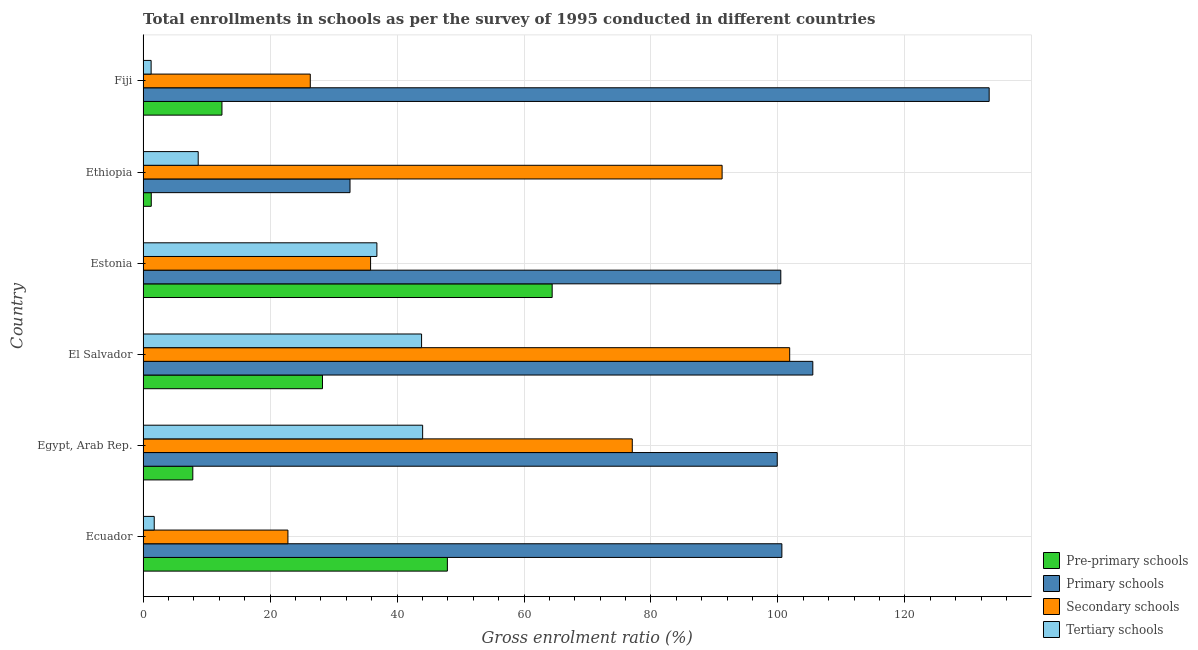How many different coloured bars are there?
Ensure brevity in your answer.  4. Are the number of bars per tick equal to the number of legend labels?
Give a very brief answer. Yes. Are the number of bars on each tick of the Y-axis equal?
Provide a succinct answer. Yes. How many bars are there on the 5th tick from the bottom?
Your answer should be compact. 4. What is the label of the 3rd group of bars from the top?
Your answer should be compact. Estonia. In how many cases, is the number of bars for a given country not equal to the number of legend labels?
Ensure brevity in your answer.  0. What is the gross enrolment ratio in tertiary schools in Egypt, Arab Rep.?
Offer a terse response. 44.04. Across all countries, what is the maximum gross enrolment ratio in tertiary schools?
Offer a terse response. 44.04. Across all countries, what is the minimum gross enrolment ratio in pre-primary schools?
Your answer should be very brief. 1.29. In which country was the gross enrolment ratio in pre-primary schools maximum?
Offer a very short reply. Estonia. In which country was the gross enrolment ratio in tertiary schools minimum?
Your answer should be compact. Fiji. What is the total gross enrolment ratio in primary schools in the graph?
Ensure brevity in your answer.  572.3. What is the difference between the gross enrolment ratio in tertiary schools in Estonia and that in Ethiopia?
Provide a short and direct response. 28.15. What is the difference between the gross enrolment ratio in secondary schools in Ecuador and the gross enrolment ratio in primary schools in El Salvador?
Keep it short and to the point. -82.67. What is the average gross enrolment ratio in tertiary schools per country?
Your response must be concise. 22.74. What is the difference between the gross enrolment ratio in secondary schools and gross enrolment ratio in pre-primary schools in Estonia?
Offer a very short reply. -28.6. What is the ratio of the gross enrolment ratio in primary schools in Egypt, Arab Rep. to that in Estonia?
Your response must be concise. 0.99. What is the difference between the highest and the second highest gross enrolment ratio in secondary schools?
Your response must be concise. 10.64. What is the difference between the highest and the lowest gross enrolment ratio in primary schools?
Offer a very short reply. 100.67. What does the 3rd bar from the top in Ecuador represents?
Offer a terse response. Primary schools. What does the 4th bar from the bottom in Estonia represents?
Give a very brief answer. Tertiary schools. How many bars are there?
Offer a very short reply. 24. How many countries are there in the graph?
Ensure brevity in your answer.  6. Are the values on the major ticks of X-axis written in scientific E-notation?
Your response must be concise. No. What is the title of the graph?
Provide a succinct answer. Total enrollments in schools as per the survey of 1995 conducted in different countries. What is the Gross enrolment ratio (%) in Pre-primary schools in Ecuador?
Provide a succinct answer. 47.93. What is the Gross enrolment ratio (%) of Primary schools in Ecuador?
Your answer should be compact. 100.62. What is the Gross enrolment ratio (%) of Secondary schools in Ecuador?
Make the answer very short. 22.81. What is the Gross enrolment ratio (%) in Tertiary schools in Ecuador?
Your answer should be very brief. 1.76. What is the Gross enrolment ratio (%) of Pre-primary schools in Egypt, Arab Rep.?
Your response must be concise. 7.84. What is the Gross enrolment ratio (%) of Primary schools in Egypt, Arab Rep.?
Your answer should be very brief. 99.88. What is the Gross enrolment ratio (%) in Secondary schools in Egypt, Arab Rep.?
Your answer should be compact. 77.05. What is the Gross enrolment ratio (%) in Tertiary schools in Egypt, Arab Rep.?
Provide a succinct answer. 44.04. What is the Gross enrolment ratio (%) in Pre-primary schools in El Salvador?
Offer a very short reply. 28.26. What is the Gross enrolment ratio (%) of Primary schools in El Salvador?
Provide a succinct answer. 105.49. What is the Gross enrolment ratio (%) in Secondary schools in El Salvador?
Provide a succinct answer. 101.85. What is the Gross enrolment ratio (%) of Tertiary schools in El Salvador?
Provide a succinct answer. 43.87. What is the Gross enrolment ratio (%) in Pre-primary schools in Estonia?
Provide a succinct answer. 64.44. What is the Gross enrolment ratio (%) in Primary schools in Estonia?
Your response must be concise. 100.45. What is the Gross enrolment ratio (%) of Secondary schools in Estonia?
Your answer should be compact. 35.84. What is the Gross enrolment ratio (%) of Tertiary schools in Estonia?
Provide a short and direct response. 36.83. What is the Gross enrolment ratio (%) of Pre-primary schools in Ethiopia?
Offer a very short reply. 1.29. What is the Gross enrolment ratio (%) of Primary schools in Ethiopia?
Make the answer very short. 32.6. What is the Gross enrolment ratio (%) in Secondary schools in Ethiopia?
Your answer should be compact. 91.2. What is the Gross enrolment ratio (%) of Tertiary schools in Ethiopia?
Your response must be concise. 8.68. What is the Gross enrolment ratio (%) of Pre-primary schools in Fiji?
Offer a terse response. 12.42. What is the Gross enrolment ratio (%) of Primary schools in Fiji?
Make the answer very short. 133.27. What is the Gross enrolment ratio (%) of Secondary schools in Fiji?
Your answer should be very brief. 26.34. What is the Gross enrolment ratio (%) in Tertiary schools in Fiji?
Provide a succinct answer. 1.27. Across all countries, what is the maximum Gross enrolment ratio (%) in Pre-primary schools?
Make the answer very short. 64.44. Across all countries, what is the maximum Gross enrolment ratio (%) of Primary schools?
Ensure brevity in your answer.  133.27. Across all countries, what is the maximum Gross enrolment ratio (%) in Secondary schools?
Keep it short and to the point. 101.85. Across all countries, what is the maximum Gross enrolment ratio (%) in Tertiary schools?
Provide a short and direct response. 44.04. Across all countries, what is the minimum Gross enrolment ratio (%) in Pre-primary schools?
Your answer should be compact. 1.29. Across all countries, what is the minimum Gross enrolment ratio (%) in Primary schools?
Ensure brevity in your answer.  32.6. Across all countries, what is the minimum Gross enrolment ratio (%) in Secondary schools?
Make the answer very short. 22.81. Across all countries, what is the minimum Gross enrolment ratio (%) in Tertiary schools?
Ensure brevity in your answer.  1.27. What is the total Gross enrolment ratio (%) of Pre-primary schools in the graph?
Offer a very short reply. 162.18. What is the total Gross enrolment ratio (%) in Primary schools in the graph?
Offer a very short reply. 572.3. What is the total Gross enrolment ratio (%) in Secondary schools in the graph?
Keep it short and to the point. 355.09. What is the total Gross enrolment ratio (%) of Tertiary schools in the graph?
Provide a succinct answer. 136.45. What is the difference between the Gross enrolment ratio (%) of Pre-primary schools in Ecuador and that in Egypt, Arab Rep.?
Ensure brevity in your answer.  40.09. What is the difference between the Gross enrolment ratio (%) of Primary schools in Ecuador and that in Egypt, Arab Rep.?
Your response must be concise. 0.73. What is the difference between the Gross enrolment ratio (%) of Secondary schools in Ecuador and that in Egypt, Arab Rep.?
Your answer should be compact. -54.24. What is the difference between the Gross enrolment ratio (%) in Tertiary schools in Ecuador and that in Egypt, Arab Rep.?
Your answer should be very brief. -42.28. What is the difference between the Gross enrolment ratio (%) of Pre-primary schools in Ecuador and that in El Salvador?
Offer a very short reply. 19.67. What is the difference between the Gross enrolment ratio (%) of Primary schools in Ecuador and that in El Salvador?
Ensure brevity in your answer.  -4.87. What is the difference between the Gross enrolment ratio (%) of Secondary schools in Ecuador and that in El Salvador?
Offer a very short reply. -79.03. What is the difference between the Gross enrolment ratio (%) of Tertiary schools in Ecuador and that in El Salvador?
Your response must be concise. -42.11. What is the difference between the Gross enrolment ratio (%) in Pre-primary schools in Ecuador and that in Estonia?
Give a very brief answer. -16.51. What is the difference between the Gross enrolment ratio (%) in Primary schools in Ecuador and that in Estonia?
Make the answer very short. 0.17. What is the difference between the Gross enrolment ratio (%) in Secondary schools in Ecuador and that in Estonia?
Give a very brief answer. -13.02. What is the difference between the Gross enrolment ratio (%) of Tertiary schools in Ecuador and that in Estonia?
Your response must be concise. -35.07. What is the difference between the Gross enrolment ratio (%) of Pre-primary schools in Ecuador and that in Ethiopia?
Offer a very short reply. 46.64. What is the difference between the Gross enrolment ratio (%) of Primary schools in Ecuador and that in Ethiopia?
Your answer should be compact. 68.02. What is the difference between the Gross enrolment ratio (%) in Secondary schools in Ecuador and that in Ethiopia?
Provide a succinct answer. -68.39. What is the difference between the Gross enrolment ratio (%) of Tertiary schools in Ecuador and that in Ethiopia?
Make the answer very short. -6.92. What is the difference between the Gross enrolment ratio (%) of Pre-primary schools in Ecuador and that in Fiji?
Your response must be concise. 35.51. What is the difference between the Gross enrolment ratio (%) of Primary schools in Ecuador and that in Fiji?
Offer a very short reply. -32.65. What is the difference between the Gross enrolment ratio (%) in Secondary schools in Ecuador and that in Fiji?
Your answer should be compact. -3.52. What is the difference between the Gross enrolment ratio (%) of Tertiary schools in Ecuador and that in Fiji?
Provide a succinct answer. 0.49. What is the difference between the Gross enrolment ratio (%) of Pre-primary schools in Egypt, Arab Rep. and that in El Salvador?
Your answer should be very brief. -20.42. What is the difference between the Gross enrolment ratio (%) in Primary schools in Egypt, Arab Rep. and that in El Salvador?
Make the answer very short. -5.6. What is the difference between the Gross enrolment ratio (%) of Secondary schools in Egypt, Arab Rep. and that in El Salvador?
Offer a very short reply. -24.79. What is the difference between the Gross enrolment ratio (%) of Tertiary schools in Egypt, Arab Rep. and that in El Salvador?
Your answer should be compact. 0.17. What is the difference between the Gross enrolment ratio (%) of Pre-primary schools in Egypt, Arab Rep. and that in Estonia?
Offer a terse response. -56.6. What is the difference between the Gross enrolment ratio (%) in Primary schools in Egypt, Arab Rep. and that in Estonia?
Your answer should be compact. -0.56. What is the difference between the Gross enrolment ratio (%) of Secondary schools in Egypt, Arab Rep. and that in Estonia?
Ensure brevity in your answer.  41.22. What is the difference between the Gross enrolment ratio (%) in Tertiary schools in Egypt, Arab Rep. and that in Estonia?
Keep it short and to the point. 7.21. What is the difference between the Gross enrolment ratio (%) of Pre-primary schools in Egypt, Arab Rep. and that in Ethiopia?
Ensure brevity in your answer.  6.55. What is the difference between the Gross enrolment ratio (%) of Primary schools in Egypt, Arab Rep. and that in Ethiopia?
Give a very brief answer. 67.29. What is the difference between the Gross enrolment ratio (%) in Secondary schools in Egypt, Arab Rep. and that in Ethiopia?
Provide a succinct answer. -14.15. What is the difference between the Gross enrolment ratio (%) of Tertiary schools in Egypt, Arab Rep. and that in Ethiopia?
Offer a very short reply. 35.35. What is the difference between the Gross enrolment ratio (%) in Pre-primary schools in Egypt, Arab Rep. and that in Fiji?
Provide a short and direct response. -4.59. What is the difference between the Gross enrolment ratio (%) in Primary schools in Egypt, Arab Rep. and that in Fiji?
Make the answer very short. -33.38. What is the difference between the Gross enrolment ratio (%) of Secondary schools in Egypt, Arab Rep. and that in Fiji?
Your answer should be very brief. 50.72. What is the difference between the Gross enrolment ratio (%) in Tertiary schools in Egypt, Arab Rep. and that in Fiji?
Your answer should be very brief. 42.77. What is the difference between the Gross enrolment ratio (%) in Pre-primary schools in El Salvador and that in Estonia?
Provide a short and direct response. -36.18. What is the difference between the Gross enrolment ratio (%) of Primary schools in El Salvador and that in Estonia?
Ensure brevity in your answer.  5.04. What is the difference between the Gross enrolment ratio (%) in Secondary schools in El Salvador and that in Estonia?
Offer a very short reply. 66.01. What is the difference between the Gross enrolment ratio (%) of Tertiary schools in El Salvador and that in Estonia?
Ensure brevity in your answer.  7.04. What is the difference between the Gross enrolment ratio (%) in Pre-primary schools in El Salvador and that in Ethiopia?
Make the answer very short. 26.97. What is the difference between the Gross enrolment ratio (%) of Primary schools in El Salvador and that in Ethiopia?
Your answer should be very brief. 72.89. What is the difference between the Gross enrolment ratio (%) in Secondary schools in El Salvador and that in Ethiopia?
Make the answer very short. 10.64. What is the difference between the Gross enrolment ratio (%) in Tertiary schools in El Salvador and that in Ethiopia?
Make the answer very short. 35.18. What is the difference between the Gross enrolment ratio (%) of Pre-primary schools in El Salvador and that in Fiji?
Provide a succinct answer. 15.83. What is the difference between the Gross enrolment ratio (%) of Primary schools in El Salvador and that in Fiji?
Your answer should be very brief. -27.78. What is the difference between the Gross enrolment ratio (%) in Secondary schools in El Salvador and that in Fiji?
Your response must be concise. 75.51. What is the difference between the Gross enrolment ratio (%) in Tertiary schools in El Salvador and that in Fiji?
Ensure brevity in your answer.  42.6. What is the difference between the Gross enrolment ratio (%) in Pre-primary schools in Estonia and that in Ethiopia?
Your answer should be very brief. 63.15. What is the difference between the Gross enrolment ratio (%) of Primary schools in Estonia and that in Ethiopia?
Your answer should be compact. 67.85. What is the difference between the Gross enrolment ratio (%) in Secondary schools in Estonia and that in Ethiopia?
Provide a succinct answer. -55.37. What is the difference between the Gross enrolment ratio (%) of Tertiary schools in Estonia and that in Ethiopia?
Offer a very short reply. 28.15. What is the difference between the Gross enrolment ratio (%) in Pre-primary schools in Estonia and that in Fiji?
Make the answer very short. 52.01. What is the difference between the Gross enrolment ratio (%) in Primary schools in Estonia and that in Fiji?
Offer a terse response. -32.82. What is the difference between the Gross enrolment ratio (%) of Secondary schools in Estonia and that in Fiji?
Your answer should be very brief. 9.5. What is the difference between the Gross enrolment ratio (%) in Tertiary schools in Estonia and that in Fiji?
Your answer should be compact. 35.56. What is the difference between the Gross enrolment ratio (%) of Pre-primary schools in Ethiopia and that in Fiji?
Give a very brief answer. -11.13. What is the difference between the Gross enrolment ratio (%) in Primary schools in Ethiopia and that in Fiji?
Offer a terse response. -100.67. What is the difference between the Gross enrolment ratio (%) in Secondary schools in Ethiopia and that in Fiji?
Provide a short and direct response. 64.86. What is the difference between the Gross enrolment ratio (%) in Tertiary schools in Ethiopia and that in Fiji?
Offer a very short reply. 7.42. What is the difference between the Gross enrolment ratio (%) of Pre-primary schools in Ecuador and the Gross enrolment ratio (%) of Primary schools in Egypt, Arab Rep.?
Offer a terse response. -51.95. What is the difference between the Gross enrolment ratio (%) of Pre-primary schools in Ecuador and the Gross enrolment ratio (%) of Secondary schools in Egypt, Arab Rep.?
Offer a terse response. -29.12. What is the difference between the Gross enrolment ratio (%) of Pre-primary schools in Ecuador and the Gross enrolment ratio (%) of Tertiary schools in Egypt, Arab Rep.?
Your answer should be very brief. 3.9. What is the difference between the Gross enrolment ratio (%) in Primary schools in Ecuador and the Gross enrolment ratio (%) in Secondary schools in Egypt, Arab Rep.?
Offer a very short reply. 23.56. What is the difference between the Gross enrolment ratio (%) in Primary schools in Ecuador and the Gross enrolment ratio (%) in Tertiary schools in Egypt, Arab Rep.?
Offer a very short reply. 56.58. What is the difference between the Gross enrolment ratio (%) in Secondary schools in Ecuador and the Gross enrolment ratio (%) in Tertiary schools in Egypt, Arab Rep.?
Your answer should be compact. -21.22. What is the difference between the Gross enrolment ratio (%) in Pre-primary schools in Ecuador and the Gross enrolment ratio (%) in Primary schools in El Salvador?
Provide a succinct answer. -57.56. What is the difference between the Gross enrolment ratio (%) in Pre-primary schools in Ecuador and the Gross enrolment ratio (%) in Secondary schools in El Salvador?
Your answer should be compact. -53.92. What is the difference between the Gross enrolment ratio (%) in Pre-primary schools in Ecuador and the Gross enrolment ratio (%) in Tertiary schools in El Salvador?
Offer a very short reply. 4.06. What is the difference between the Gross enrolment ratio (%) of Primary schools in Ecuador and the Gross enrolment ratio (%) of Secondary schools in El Salvador?
Your answer should be compact. -1.23. What is the difference between the Gross enrolment ratio (%) of Primary schools in Ecuador and the Gross enrolment ratio (%) of Tertiary schools in El Salvador?
Give a very brief answer. 56.75. What is the difference between the Gross enrolment ratio (%) in Secondary schools in Ecuador and the Gross enrolment ratio (%) in Tertiary schools in El Salvador?
Offer a very short reply. -21.05. What is the difference between the Gross enrolment ratio (%) of Pre-primary schools in Ecuador and the Gross enrolment ratio (%) of Primary schools in Estonia?
Provide a short and direct response. -52.51. What is the difference between the Gross enrolment ratio (%) of Pre-primary schools in Ecuador and the Gross enrolment ratio (%) of Secondary schools in Estonia?
Your answer should be very brief. 12.1. What is the difference between the Gross enrolment ratio (%) in Pre-primary schools in Ecuador and the Gross enrolment ratio (%) in Tertiary schools in Estonia?
Your answer should be compact. 11.1. What is the difference between the Gross enrolment ratio (%) in Primary schools in Ecuador and the Gross enrolment ratio (%) in Secondary schools in Estonia?
Your answer should be compact. 64.78. What is the difference between the Gross enrolment ratio (%) in Primary schools in Ecuador and the Gross enrolment ratio (%) in Tertiary schools in Estonia?
Your answer should be very brief. 63.79. What is the difference between the Gross enrolment ratio (%) in Secondary schools in Ecuador and the Gross enrolment ratio (%) in Tertiary schools in Estonia?
Offer a very short reply. -14.02. What is the difference between the Gross enrolment ratio (%) in Pre-primary schools in Ecuador and the Gross enrolment ratio (%) in Primary schools in Ethiopia?
Give a very brief answer. 15.34. What is the difference between the Gross enrolment ratio (%) in Pre-primary schools in Ecuador and the Gross enrolment ratio (%) in Secondary schools in Ethiopia?
Keep it short and to the point. -43.27. What is the difference between the Gross enrolment ratio (%) in Pre-primary schools in Ecuador and the Gross enrolment ratio (%) in Tertiary schools in Ethiopia?
Give a very brief answer. 39.25. What is the difference between the Gross enrolment ratio (%) in Primary schools in Ecuador and the Gross enrolment ratio (%) in Secondary schools in Ethiopia?
Ensure brevity in your answer.  9.41. What is the difference between the Gross enrolment ratio (%) in Primary schools in Ecuador and the Gross enrolment ratio (%) in Tertiary schools in Ethiopia?
Keep it short and to the point. 91.93. What is the difference between the Gross enrolment ratio (%) in Secondary schools in Ecuador and the Gross enrolment ratio (%) in Tertiary schools in Ethiopia?
Your answer should be very brief. 14.13. What is the difference between the Gross enrolment ratio (%) in Pre-primary schools in Ecuador and the Gross enrolment ratio (%) in Primary schools in Fiji?
Give a very brief answer. -85.34. What is the difference between the Gross enrolment ratio (%) of Pre-primary schools in Ecuador and the Gross enrolment ratio (%) of Secondary schools in Fiji?
Give a very brief answer. 21.59. What is the difference between the Gross enrolment ratio (%) in Pre-primary schools in Ecuador and the Gross enrolment ratio (%) in Tertiary schools in Fiji?
Keep it short and to the point. 46.66. What is the difference between the Gross enrolment ratio (%) of Primary schools in Ecuador and the Gross enrolment ratio (%) of Secondary schools in Fiji?
Keep it short and to the point. 74.28. What is the difference between the Gross enrolment ratio (%) in Primary schools in Ecuador and the Gross enrolment ratio (%) in Tertiary schools in Fiji?
Your response must be concise. 99.35. What is the difference between the Gross enrolment ratio (%) of Secondary schools in Ecuador and the Gross enrolment ratio (%) of Tertiary schools in Fiji?
Offer a very short reply. 21.55. What is the difference between the Gross enrolment ratio (%) in Pre-primary schools in Egypt, Arab Rep. and the Gross enrolment ratio (%) in Primary schools in El Salvador?
Provide a short and direct response. -97.65. What is the difference between the Gross enrolment ratio (%) in Pre-primary schools in Egypt, Arab Rep. and the Gross enrolment ratio (%) in Secondary schools in El Salvador?
Your answer should be very brief. -94.01. What is the difference between the Gross enrolment ratio (%) in Pre-primary schools in Egypt, Arab Rep. and the Gross enrolment ratio (%) in Tertiary schools in El Salvador?
Provide a short and direct response. -36.03. What is the difference between the Gross enrolment ratio (%) of Primary schools in Egypt, Arab Rep. and the Gross enrolment ratio (%) of Secondary schools in El Salvador?
Provide a succinct answer. -1.96. What is the difference between the Gross enrolment ratio (%) in Primary schools in Egypt, Arab Rep. and the Gross enrolment ratio (%) in Tertiary schools in El Salvador?
Provide a short and direct response. 56.02. What is the difference between the Gross enrolment ratio (%) of Secondary schools in Egypt, Arab Rep. and the Gross enrolment ratio (%) of Tertiary schools in El Salvador?
Offer a very short reply. 33.19. What is the difference between the Gross enrolment ratio (%) in Pre-primary schools in Egypt, Arab Rep. and the Gross enrolment ratio (%) in Primary schools in Estonia?
Provide a succinct answer. -92.61. What is the difference between the Gross enrolment ratio (%) in Pre-primary schools in Egypt, Arab Rep. and the Gross enrolment ratio (%) in Secondary schools in Estonia?
Give a very brief answer. -28. What is the difference between the Gross enrolment ratio (%) in Pre-primary schools in Egypt, Arab Rep. and the Gross enrolment ratio (%) in Tertiary schools in Estonia?
Give a very brief answer. -28.99. What is the difference between the Gross enrolment ratio (%) of Primary schools in Egypt, Arab Rep. and the Gross enrolment ratio (%) of Secondary schools in Estonia?
Make the answer very short. 64.05. What is the difference between the Gross enrolment ratio (%) in Primary schools in Egypt, Arab Rep. and the Gross enrolment ratio (%) in Tertiary schools in Estonia?
Make the answer very short. 63.05. What is the difference between the Gross enrolment ratio (%) of Secondary schools in Egypt, Arab Rep. and the Gross enrolment ratio (%) of Tertiary schools in Estonia?
Ensure brevity in your answer.  40.22. What is the difference between the Gross enrolment ratio (%) of Pre-primary schools in Egypt, Arab Rep. and the Gross enrolment ratio (%) of Primary schools in Ethiopia?
Your response must be concise. -24.76. What is the difference between the Gross enrolment ratio (%) of Pre-primary schools in Egypt, Arab Rep. and the Gross enrolment ratio (%) of Secondary schools in Ethiopia?
Your answer should be compact. -83.37. What is the difference between the Gross enrolment ratio (%) in Pre-primary schools in Egypt, Arab Rep. and the Gross enrolment ratio (%) in Tertiary schools in Ethiopia?
Give a very brief answer. -0.85. What is the difference between the Gross enrolment ratio (%) in Primary schools in Egypt, Arab Rep. and the Gross enrolment ratio (%) in Secondary schools in Ethiopia?
Your response must be concise. 8.68. What is the difference between the Gross enrolment ratio (%) in Primary schools in Egypt, Arab Rep. and the Gross enrolment ratio (%) in Tertiary schools in Ethiopia?
Offer a terse response. 91.2. What is the difference between the Gross enrolment ratio (%) in Secondary schools in Egypt, Arab Rep. and the Gross enrolment ratio (%) in Tertiary schools in Ethiopia?
Provide a succinct answer. 68.37. What is the difference between the Gross enrolment ratio (%) in Pre-primary schools in Egypt, Arab Rep. and the Gross enrolment ratio (%) in Primary schools in Fiji?
Provide a short and direct response. -125.43. What is the difference between the Gross enrolment ratio (%) of Pre-primary schools in Egypt, Arab Rep. and the Gross enrolment ratio (%) of Secondary schools in Fiji?
Provide a succinct answer. -18.5. What is the difference between the Gross enrolment ratio (%) in Pre-primary schools in Egypt, Arab Rep. and the Gross enrolment ratio (%) in Tertiary schools in Fiji?
Provide a short and direct response. 6.57. What is the difference between the Gross enrolment ratio (%) of Primary schools in Egypt, Arab Rep. and the Gross enrolment ratio (%) of Secondary schools in Fiji?
Ensure brevity in your answer.  73.55. What is the difference between the Gross enrolment ratio (%) of Primary schools in Egypt, Arab Rep. and the Gross enrolment ratio (%) of Tertiary schools in Fiji?
Ensure brevity in your answer.  98.62. What is the difference between the Gross enrolment ratio (%) of Secondary schools in Egypt, Arab Rep. and the Gross enrolment ratio (%) of Tertiary schools in Fiji?
Make the answer very short. 75.78. What is the difference between the Gross enrolment ratio (%) of Pre-primary schools in El Salvador and the Gross enrolment ratio (%) of Primary schools in Estonia?
Your response must be concise. -72.19. What is the difference between the Gross enrolment ratio (%) in Pre-primary schools in El Salvador and the Gross enrolment ratio (%) in Secondary schools in Estonia?
Provide a short and direct response. -7.58. What is the difference between the Gross enrolment ratio (%) in Pre-primary schools in El Salvador and the Gross enrolment ratio (%) in Tertiary schools in Estonia?
Ensure brevity in your answer.  -8.57. What is the difference between the Gross enrolment ratio (%) of Primary schools in El Salvador and the Gross enrolment ratio (%) of Secondary schools in Estonia?
Give a very brief answer. 69.65. What is the difference between the Gross enrolment ratio (%) in Primary schools in El Salvador and the Gross enrolment ratio (%) in Tertiary schools in Estonia?
Offer a very short reply. 68.66. What is the difference between the Gross enrolment ratio (%) in Secondary schools in El Salvador and the Gross enrolment ratio (%) in Tertiary schools in Estonia?
Provide a short and direct response. 65.02. What is the difference between the Gross enrolment ratio (%) in Pre-primary schools in El Salvador and the Gross enrolment ratio (%) in Primary schools in Ethiopia?
Provide a succinct answer. -4.34. What is the difference between the Gross enrolment ratio (%) in Pre-primary schools in El Salvador and the Gross enrolment ratio (%) in Secondary schools in Ethiopia?
Give a very brief answer. -62.94. What is the difference between the Gross enrolment ratio (%) in Pre-primary schools in El Salvador and the Gross enrolment ratio (%) in Tertiary schools in Ethiopia?
Make the answer very short. 19.57. What is the difference between the Gross enrolment ratio (%) of Primary schools in El Salvador and the Gross enrolment ratio (%) of Secondary schools in Ethiopia?
Your answer should be very brief. 14.29. What is the difference between the Gross enrolment ratio (%) of Primary schools in El Salvador and the Gross enrolment ratio (%) of Tertiary schools in Ethiopia?
Make the answer very short. 96.8. What is the difference between the Gross enrolment ratio (%) in Secondary schools in El Salvador and the Gross enrolment ratio (%) in Tertiary schools in Ethiopia?
Ensure brevity in your answer.  93.16. What is the difference between the Gross enrolment ratio (%) of Pre-primary schools in El Salvador and the Gross enrolment ratio (%) of Primary schools in Fiji?
Offer a very short reply. -105.01. What is the difference between the Gross enrolment ratio (%) of Pre-primary schools in El Salvador and the Gross enrolment ratio (%) of Secondary schools in Fiji?
Give a very brief answer. 1.92. What is the difference between the Gross enrolment ratio (%) in Pre-primary schools in El Salvador and the Gross enrolment ratio (%) in Tertiary schools in Fiji?
Offer a terse response. 26.99. What is the difference between the Gross enrolment ratio (%) of Primary schools in El Salvador and the Gross enrolment ratio (%) of Secondary schools in Fiji?
Make the answer very short. 79.15. What is the difference between the Gross enrolment ratio (%) in Primary schools in El Salvador and the Gross enrolment ratio (%) in Tertiary schools in Fiji?
Provide a succinct answer. 104.22. What is the difference between the Gross enrolment ratio (%) of Secondary schools in El Salvador and the Gross enrolment ratio (%) of Tertiary schools in Fiji?
Your answer should be very brief. 100.58. What is the difference between the Gross enrolment ratio (%) of Pre-primary schools in Estonia and the Gross enrolment ratio (%) of Primary schools in Ethiopia?
Ensure brevity in your answer.  31.84. What is the difference between the Gross enrolment ratio (%) in Pre-primary schools in Estonia and the Gross enrolment ratio (%) in Secondary schools in Ethiopia?
Provide a succinct answer. -26.77. What is the difference between the Gross enrolment ratio (%) of Pre-primary schools in Estonia and the Gross enrolment ratio (%) of Tertiary schools in Ethiopia?
Your response must be concise. 55.75. What is the difference between the Gross enrolment ratio (%) of Primary schools in Estonia and the Gross enrolment ratio (%) of Secondary schools in Ethiopia?
Your answer should be compact. 9.24. What is the difference between the Gross enrolment ratio (%) of Primary schools in Estonia and the Gross enrolment ratio (%) of Tertiary schools in Ethiopia?
Give a very brief answer. 91.76. What is the difference between the Gross enrolment ratio (%) in Secondary schools in Estonia and the Gross enrolment ratio (%) in Tertiary schools in Ethiopia?
Ensure brevity in your answer.  27.15. What is the difference between the Gross enrolment ratio (%) of Pre-primary schools in Estonia and the Gross enrolment ratio (%) of Primary schools in Fiji?
Provide a short and direct response. -68.83. What is the difference between the Gross enrolment ratio (%) of Pre-primary schools in Estonia and the Gross enrolment ratio (%) of Secondary schools in Fiji?
Your response must be concise. 38.1. What is the difference between the Gross enrolment ratio (%) in Pre-primary schools in Estonia and the Gross enrolment ratio (%) in Tertiary schools in Fiji?
Your response must be concise. 63.17. What is the difference between the Gross enrolment ratio (%) of Primary schools in Estonia and the Gross enrolment ratio (%) of Secondary schools in Fiji?
Ensure brevity in your answer.  74.11. What is the difference between the Gross enrolment ratio (%) in Primary schools in Estonia and the Gross enrolment ratio (%) in Tertiary schools in Fiji?
Keep it short and to the point. 99.18. What is the difference between the Gross enrolment ratio (%) of Secondary schools in Estonia and the Gross enrolment ratio (%) of Tertiary schools in Fiji?
Offer a terse response. 34.57. What is the difference between the Gross enrolment ratio (%) in Pre-primary schools in Ethiopia and the Gross enrolment ratio (%) in Primary schools in Fiji?
Offer a terse response. -131.98. What is the difference between the Gross enrolment ratio (%) in Pre-primary schools in Ethiopia and the Gross enrolment ratio (%) in Secondary schools in Fiji?
Keep it short and to the point. -25.05. What is the difference between the Gross enrolment ratio (%) of Pre-primary schools in Ethiopia and the Gross enrolment ratio (%) of Tertiary schools in Fiji?
Offer a very short reply. 0.02. What is the difference between the Gross enrolment ratio (%) of Primary schools in Ethiopia and the Gross enrolment ratio (%) of Secondary schools in Fiji?
Give a very brief answer. 6.26. What is the difference between the Gross enrolment ratio (%) in Primary schools in Ethiopia and the Gross enrolment ratio (%) in Tertiary schools in Fiji?
Offer a very short reply. 31.33. What is the difference between the Gross enrolment ratio (%) of Secondary schools in Ethiopia and the Gross enrolment ratio (%) of Tertiary schools in Fiji?
Offer a terse response. 89.93. What is the average Gross enrolment ratio (%) of Pre-primary schools per country?
Keep it short and to the point. 27.03. What is the average Gross enrolment ratio (%) in Primary schools per country?
Offer a very short reply. 95.38. What is the average Gross enrolment ratio (%) in Secondary schools per country?
Your answer should be very brief. 59.18. What is the average Gross enrolment ratio (%) in Tertiary schools per country?
Offer a very short reply. 22.74. What is the difference between the Gross enrolment ratio (%) in Pre-primary schools and Gross enrolment ratio (%) in Primary schools in Ecuador?
Offer a very short reply. -52.69. What is the difference between the Gross enrolment ratio (%) in Pre-primary schools and Gross enrolment ratio (%) in Secondary schools in Ecuador?
Your answer should be compact. 25.12. What is the difference between the Gross enrolment ratio (%) of Pre-primary schools and Gross enrolment ratio (%) of Tertiary schools in Ecuador?
Provide a short and direct response. 46.17. What is the difference between the Gross enrolment ratio (%) in Primary schools and Gross enrolment ratio (%) in Secondary schools in Ecuador?
Provide a succinct answer. 77.8. What is the difference between the Gross enrolment ratio (%) of Primary schools and Gross enrolment ratio (%) of Tertiary schools in Ecuador?
Offer a very short reply. 98.86. What is the difference between the Gross enrolment ratio (%) in Secondary schools and Gross enrolment ratio (%) in Tertiary schools in Ecuador?
Your answer should be compact. 21.06. What is the difference between the Gross enrolment ratio (%) of Pre-primary schools and Gross enrolment ratio (%) of Primary schools in Egypt, Arab Rep.?
Your answer should be very brief. -92.05. What is the difference between the Gross enrolment ratio (%) of Pre-primary schools and Gross enrolment ratio (%) of Secondary schools in Egypt, Arab Rep.?
Ensure brevity in your answer.  -69.22. What is the difference between the Gross enrolment ratio (%) of Pre-primary schools and Gross enrolment ratio (%) of Tertiary schools in Egypt, Arab Rep.?
Provide a succinct answer. -36.2. What is the difference between the Gross enrolment ratio (%) of Primary schools and Gross enrolment ratio (%) of Secondary schools in Egypt, Arab Rep.?
Keep it short and to the point. 22.83. What is the difference between the Gross enrolment ratio (%) in Primary schools and Gross enrolment ratio (%) in Tertiary schools in Egypt, Arab Rep.?
Provide a succinct answer. 55.85. What is the difference between the Gross enrolment ratio (%) in Secondary schools and Gross enrolment ratio (%) in Tertiary schools in Egypt, Arab Rep.?
Your response must be concise. 33.02. What is the difference between the Gross enrolment ratio (%) in Pre-primary schools and Gross enrolment ratio (%) in Primary schools in El Salvador?
Keep it short and to the point. -77.23. What is the difference between the Gross enrolment ratio (%) in Pre-primary schools and Gross enrolment ratio (%) in Secondary schools in El Salvador?
Give a very brief answer. -73.59. What is the difference between the Gross enrolment ratio (%) of Pre-primary schools and Gross enrolment ratio (%) of Tertiary schools in El Salvador?
Your response must be concise. -15.61. What is the difference between the Gross enrolment ratio (%) of Primary schools and Gross enrolment ratio (%) of Secondary schools in El Salvador?
Offer a terse response. 3.64. What is the difference between the Gross enrolment ratio (%) of Primary schools and Gross enrolment ratio (%) of Tertiary schools in El Salvador?
Provide a succinct answer. 61.62. What is the difference between the Gross enrolment ratio (%) in Secondary schools and Gross enrolment ratio (%) in Tertiary schools in El Salvador?
Provide a succinct answer. 57.98. What is the difference between the Gross enrolment ratio (%) of Pre-primary schools and Gross enrolment ratio (%) of Primary schools in Estonia?
Your response must be concise. -36.01. What is the difference between the Gross enrolment ratio (%) of Pre-primary schools and Gross enrolment ratio (%) of Secondary schools in Estonia?
Keep it short and to the point. 28.6. What is the difference between the Gross enrolment ratio (%) in Pre-primary schools and Gross enrolment ratio (%) in Tertiary schools in Estonia?
Ensure brevity in your answer.  27.61. What is the difference between the Gross enrolment ratio (%) of Primary schools and Gross enrolment ratio (%) of Secondary schools in Estonia?
Your answer should be compact. 64.61. What is the difference between the Gross enrolment ratio (%) in Primary schools and Gross enrolment ratio (%) in Tertiary schools in Estonia?
Keep it short and to the point. 63.62. What is the difference between the Gross enrolment ratio (%) in Secondary schools and Gross enrolment ratio (%) in Tertiary schools in Estonia?
Your response must be concise. -0.99. What is the difference between the Gross enrolment ratio (%) in Pre-primary schools and Gross enrolment ratio (%) in Primary schools in Ethiopia?
Your answer should be very brief. -31.3. What is the difference between the Gross enrolment ratio (%) of Pre-primary schools and Gross enrolment ratio (%) of Secondary schools in Ethiopia?
Keep it short and to the point. -89.91. What is the difference between the Gross enrolment ratio (%) of Pre-primary schools and Gross enrolment ratio (%) of Tertiary schools in Ethiopia?
Provide a short and direct response. -7.39. What is the difference between the Gross enrolment ratio (%) in Primary schools and Gross enrolment ratio (%) in Secondary schools in Ethiopia?
Your answer should be compact. -58.61. What is the difference between the Gross enrolment ratio (%) in Primary schools and Gross enrolment ratio (%) in Tertiary schools in Ethiopia?
Provide a short and direct response. 23.91. What is the difference between the Gross enrolment ratio (%) in Secondary schools and Gross enrolment ratio (%) in Tertiary schools in Ethiopia?
Make the answer very short. 82.52. What is the difference between the Gross enrolment ratio (%) of Pre-primary schools and Gross enrolment ratio (%) of Primary schools in Fiji?
Ensure brevity in your answer.  -120.84. What is the difference between the Gross enrolment ratio (%) of Pre-primary schools and Gross enrolment ratio (%) of Secondary schools in Fiji?
Your response must be concise. -13.91. What is the difference between the Gross enrolment ratio (%) in Pre-primary schools and Gross enrolment ratio (%) in Tertiary schools in Fiji?
Your answer should be very brief. 11.16. What is the difference between the Gross enrolment ratio (%) of Primary schools and Gross enrolment ratio (%) of Secondary schools in Fiji?
Your response must be concise. 106.93. What is the difference between the Gross enrolment ratio (%) of Primary schools and Gross enrolment ratio (%) of Tertiary schools in Fiji?
Provide a short and direct response. 132. What is the difference between the Gross enrolment ratio (%) in Secondary schools and Gross enrolment ratio (%) in Tertiary schools in Fiji?
Make the answer very short. 25.07. What is the ratio of the Gross enrolment ratio (%) of Pre-primary schools in Ecuador to that in Egypt, Arab Rep.?
Your response must be concise. 6.12. What is the ratio of the Gross enrolment ratio (%) of Primary schools in Ecuador to that in Egypt, Arab Rep.?
Your answer should be very brief. 1.01. What is the ratio of the Gross enrolment ratio (%) in Secondary schools in Ecuador to that in Egypt, Arab Rep.?
Your answer should be compact. 0.3. What is the ratio of the Gross enrolment ratio (%) in Tertiary schools in Ecuador to that in Egypt, Arab Rep.?
Provide a short and direct response. 0.04. What is the ratio of the Gross enrolment ratio (%) in Pre-primary schools in Ecuador to that in El Salvador?
Your response must be concise. 1.7. What is the ratio of the Gross enrolment ratio (%) of Primary schools in Ecuador to that in El Salvador?
Keep it short and to the point. 0.95. What is the ratio of the Gross enrolment ratio (%) of Secondary schools in Ecuador to that in El Salvador?
Provide a succinct answer. 0.22. What is the ratio of the Gross enrolment ratio (%) in Tertiary schools in Ecuador to that in El Salvador?
Provide a short and direct response. 0.04. What is the ratio of the Gross enrolment ratio (%) of Pre-primary schools in Ecuador to that in Estonia?
Offer a very short reply. 0.74. What is the ratio of the Gross enrolment ratio (%) in Secondary schools in Ecuador to that in Estonia?
Keep it short and to the point. 0.64. What is the ratio of the Gross enrolment ratio (%) of Tertiary schools in Ecuador to that in Estonia?
Provide a succinct answer. 0.05. What is the ratio of the Gross enrolment ratio (%) of Pre-primary schools in Ecuador to that in Ethiopia?
Offer a very short reply. 37.13. What is the ratio of the Gross enrolment ratio (%) of Primary schools in Ecuador to that in Ethiopia?
Your answer should be compact. 3.09. What is the ratio of the Gross enrolment ratio (%) in Secondary schools in Ecuador to that in Ethiopia?
Your answer should be very brief. 0.25. What is the ratio of the Gross enrolment ratio (%) in Tertiary schools in Ecuador to that in Ethiopia?
Keep it short and to the point. 0.2. What is the ratio of the Gross enrolment ratio (%) of Pre-primary schools in Ecuador to that in Fiji?
Make the answer very short. 3.86. What is the ratio of the Gross enrolment ratio (%) in Primary schools in Ecuador to that in Fiji?
Provide a short and direct response. 0.76. What is the ratio of the Gross enrolment ratio (%) of Secondary schools in Ecuador to that in Fiji?
Your answer should be very brief. 0.87. What is the ratio of the Gross enrolment ratio (%) of Tertiary schools in Ecuador to that in Fiji?
Provide a short and direct response. 1.39. What is the ratio of the Gross enrolment ratio (%) in Pre-primary schools in Egypt, Arab Rep. to that in El Salvador?
Give a very brief answer. 0.28. What is the ratio of the Gross enrolment ratio (%) of Primary schools in Egypt, Arab Rep. to that in El Salvador?
Offer a very short reply. 0.95. What is the ratio of the Gross enrolment ratio (%) in Secondary schools in Egypt, Arab Rep. to that in El Salvador?
Make the answer very short. 0.76. What is the ratio of the Gross enrolment ratio (%) in Tertiary schools in Egypt, Arab Rep. to that in El Salvador?
Provide a succinct answer. 1. What is the ratio of the Gross enrolment ratio (%) of Pre-primary schools in Egypt, Arab Rep. to that in Estonia?
Ensure brevity in your answer.  0.12. What is the ratio of the Gross enrolment ratio (%) in Secondary schools in Egypt, Arab Rep. to that in Estonia?
Provide a short and direct response. 2.15. What is the ratio of the Gross enrolment ratio (%) of Tertiary schools in Egypt, Arab Rep. to that in Estonia?
Your answer should be very brief. 1.2. What is the ratio of the Gross enrolment ratio (%) of Pre-primary schools in Egypt, Arab Rep. to that in Ethiopia?
Provide a short and direct response. 6.07. What is the ratio of the Gross enrolment ratio (%) in Primary schools in Egypt, Arab Rep. to that in Ethiopia?
Provide a short and direct response. 3.06. What is the ratio of the Gross enrolment ratio (%) in Secondary schools in Egypt, Arab Rep. to that in Ethiopia?
Provide a succinct answer. 0.84. What is the ratio of the Gross enrolment ratio (%) of Tertiary schools in Egypt, Arab Rep. to that in Ethiopia?
Offer a terse response. 5.07. What is the ratio of the Gross enrolment ratio (%) in Pre-primary schools in Egypt, Arab Rep. to that in Fiji?
Your answer should be compact. 0.63. What is the ratio of the Gross enrolment ratio (%) in Primary schools in Egypt, Arab Rep. to that in Fiji?
Your answer should be very brief. 0.75. What is the ratio of the Gross enrolment ratio (%) of Secondary schools in Egypt, Arab Rep. to that in Fiji?
Your answer should be compact. 2.93. What is the ratio of the Gross enrolment ratio (%) in Tertiary schools in Egypt, Arab Rep. to that in Fiji?
Offer a very short reply. 34.7. What is the ratio of the Gross enrolment ratio (%) of Pre-primary schools in El Salvador to that in Estonia?
Provide a succinct answer. 0.44. What is the ratio of the Gross enrolment ratio (%) of Primary schools in El Salvador to that in Estonia?
Your answer should be very brief. 1.05. What is the ratio of the Gross enrolment ratio (%) in Secondary schools in El Salvador to that in Estonia?
Ensure brevity in your answer.  2.84. What is the ratio of the Gross enrolment ratio (%) of Tertiary schools in El Salvador to that in Estonia?
Your answer should be compact. 1.19. What is the ratio of the Gross enrolment ratio (%) of Pre-primary schools in El Salvador to that in Ethiopia?
Keep it short and to the point. 21.89. What is the ratio of the Gross enrolment ratio (%) in Primary schools in El Salvador to that in Ethiopia?
Provide a succinct answer. 3.24. What is the ratio of the Gross enrolment ratio (%) in Secondary schools in El Salvador to that in Ethiopia?
Provide a succinct answer. 1.12. What is the ratio of the Gross enrolment ratio (%) of Tertiary schools in El Salvador to that in Ethiopia?
Offer a very short reply. 5.05. What is the ratio of the Gross enrolment ratio (%) in Pre-primary schools in El Salvador to that in Fiji?
Provide a short and direct response. 2.27. What is the ratio of the Gross enrolment ratio (%) in Primary schools in El Salvador to that in Fiji?
Offer a very short reply. 0.79. What is the ratio of the Gross enrolment ratio (%) in Secondary schools in El Salvador to that in Fiji?
Keep it short and to the point. 3.87. What is the ratio of the Gross enrolment ratio (%) in Tertiary schools in El Salvador to that in Fiji?
Offer a terse response. 34.56. What is the ratio of the Gross enrolment ratio (%) in Pre-primary schools in Estonia to that in Ethiopia?
Your response must be concise. 49.91. What is the ratio of the Gross enrolment ratio (%) of Primary schools in Estonia to that in Ethiopia?
Make the answer very short. 3.08. What is the ratio of the Gross enrolment ratio (%) in Secondary schools in Estonia to that in Ethiopia?
Keep it short and to the point. 0.39. What is the ratio of the Gross enrolment ratio (%) in Tertiary schools in Estonia to that in Ethiopia?
Make the answer very short. 4.24. What is the ratio of the Gross enrolment ratio (%) of Pre-primary schools in Estonia to that in Fiji?
Make the answer very short. 5.19. What is the ratio of the Gross enrolment ratio (%) of Primary schools in Estonia to that in Fiji?
Your answer should be very brief. 0.75. What is the ratio of the Gross enrolment ratio (%) in Secondary schools in Estonia to that in Fiji?
Offer a terse response. 1.36. What is the ratio of the Gross enrolment ratio (%) of Tertiary schools in Estonia to that in Fiji?
Offer a very short reply. 29.02. What is the ratio of the Gross enrolment ratio (%) in Pre-primary schools in Ethiopia to that in Fiji?
Provide a short and direct response. 0.1. What is the ratio of the Gross enrolment ratio (%) in Primary schools in Ethiopia to that in Fiji?
Make the answer very short. 0.24. What is the ratio of the Gross enrolment ratio (%) of Secondary schools in Ethiopia to that in Fiji?
Give a very brief answer. 3.46. What is the ratio of the Gross enrolment ratio (%) of Tertiary schools in Ethiopia to that in Fiji?
Offer a terse response. 6.84. What is the difference between the highest and the second highest Gross enrolment ratio (%) of Pre-primary schools?
Your answer should be very brief. 16.51. What is the difference between the highest and the second highest Gross enrolment ratio (%) in Primary schools?
Give a very brief answer. 27.78. What is the difference between the highest and the second highest Gross enrolment ratio (%) of Secondary schools?
Give a very brief answer. 10.64. What is the difference between the highest and the second highest Gross enrolment ratio (%) in Tertiary schools?
Your answer should be compact. 0.17. What is the difference between the highest and the lowest Gross enrolment ratio (%) in Pre-primary schools?
Provide a succinct answer. 63.15. What is the difference between the highest and the lowest Gross enrolment ratio (%) of Primary schools?
Your answer should be compact. 100.67. What is the difference between the highest and the lowest Gross enrolment ratio (%) in Secondary schools?
Offer a terse response. 79.03. What is the difference between the highest and the lowest Gross enrolment ratio (%) in Tertiary schools?
Provide a short and direct response. 42.77. 